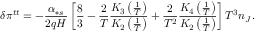<formula> <loc_0><loc_0><loc_500><loc_500>\delta \pi ^ { t t } = - \frac { \alpha _ { \ast s } } { 2 q H } \left [ \frac { 8 } { 3 } - \frac { 2 } { T } \frac { K _ { 3 } \left ( \frac { 1 } { T } \right ) } { K _ { 2 } \left ( \frac { 1 } { T } \right ) } + \frac { 2 } { T ^ { 2 } } \frac { K _ { 4 } \left ( \frac { 1 } { T } \right ) } { K _ { 2 } \left ( \frac { 1 } { T } \right ) } \right ] T ^ { 3 } n _ { J } .</formula> 